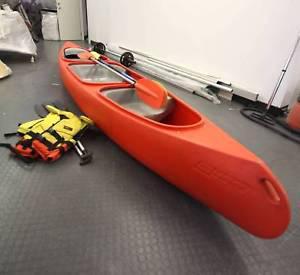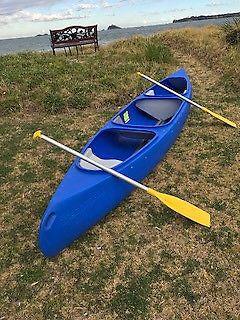The first image is the image on the left, the second image is the image on the right. Considering the images on both sides, is "All of the canoes and kayaks have oars on them." valid? Answer yes or no. Yes. The first image is the image on the left, the second image is the image on the right. For the images shown, is this caption "The left image has a red canoe with a paddle on it." true? Answer yes or no. Yes. 